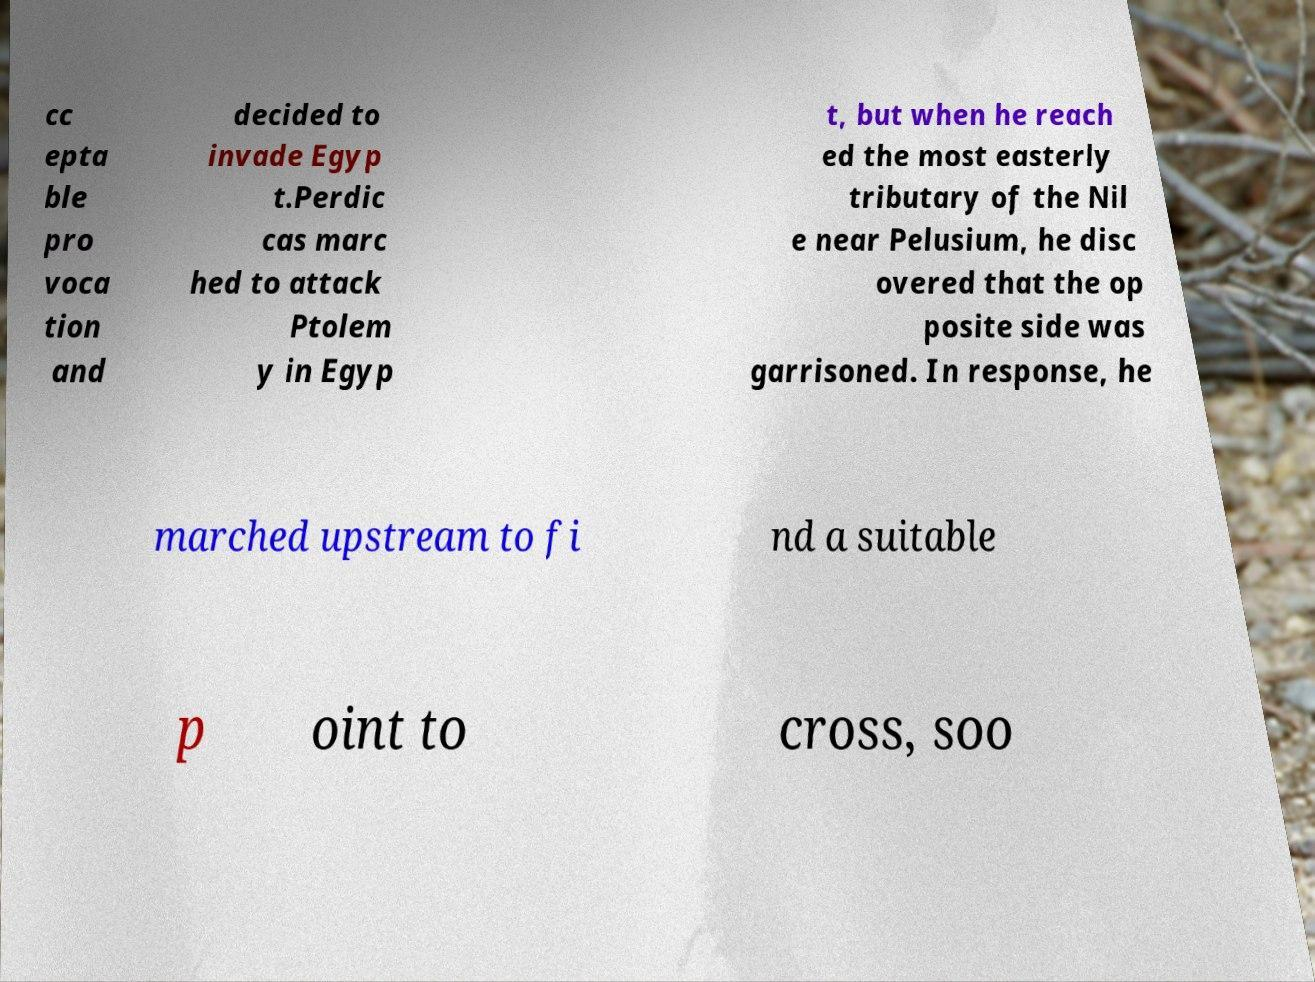There's text embedded in this image that I need extracted. Can you transcribe it verbatim? cc epta ble pro voca tion and decided to invade Egyp t.Perdic cas marc hed to attack Ptolem y in Egyp t, but when he reach ed the most easterly tributary of the Nil e near Pelusium, he disc overed that the op posite side was garrisoned. In response, he marched upstream to fi nd a suitable p oint to cross, soo 